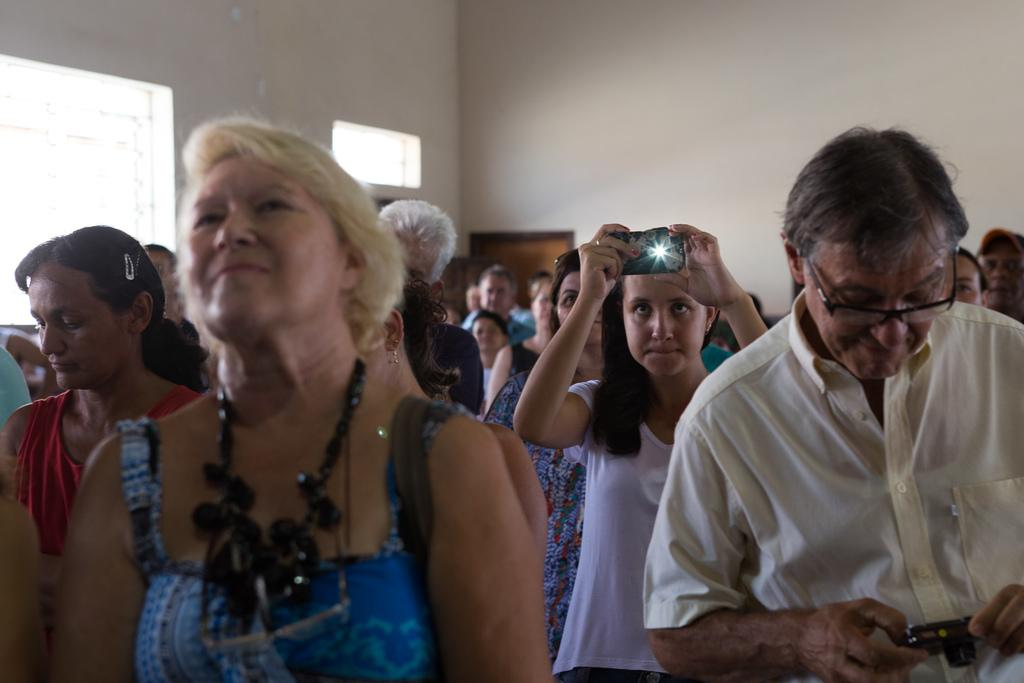How many people are in the image? There are multiple persons in the image. What are some of the persons doing in the image? Some of the persons are holding cameras. What can be seen in the background of the image? There is a wall, a window, and a brown-colored door in the background of the image. What country is the friend from in the image? There is no friend mentioned in the image, nor any indication of a country of origin. 